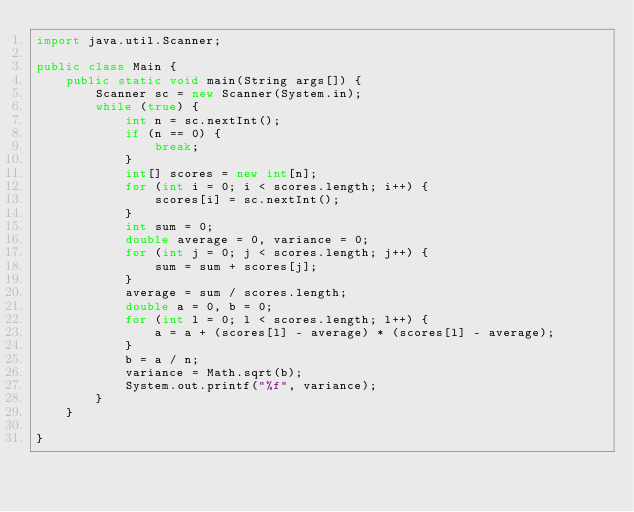<code> <loc_0><loc_0><loc_500><loc_500><_Java_>import java.util.Scanner;

public class Main {
	public static void main(String args[]) {
		Scanner sc = new Scanner(System.in);
		while (true) {
			int n = sc.nextInt();
			if (n == 0) {
				break;
			}
			int[] scores = new int[n];
			for (int i = 0; i < scores.length; i++) {
				scores[i] = sc.nextInt();
			}
			int sum = 0;
			double average = 0, variance = 0;
			for (int j = 0; j < scores.length; j++) {
				sum = sum + scores[j];
			}
			average = sum / scores.length;
			double a = 0, b = 0;
			for (int l = 0; l < scores.length; l++) {
				a = a + (scores[l] - average) * (scores[l] - average);
			}
			b = a / n;
			variance = Math.sqrt(b);
			System.out.printf("%f", variance);
		}
	}

}</code> 